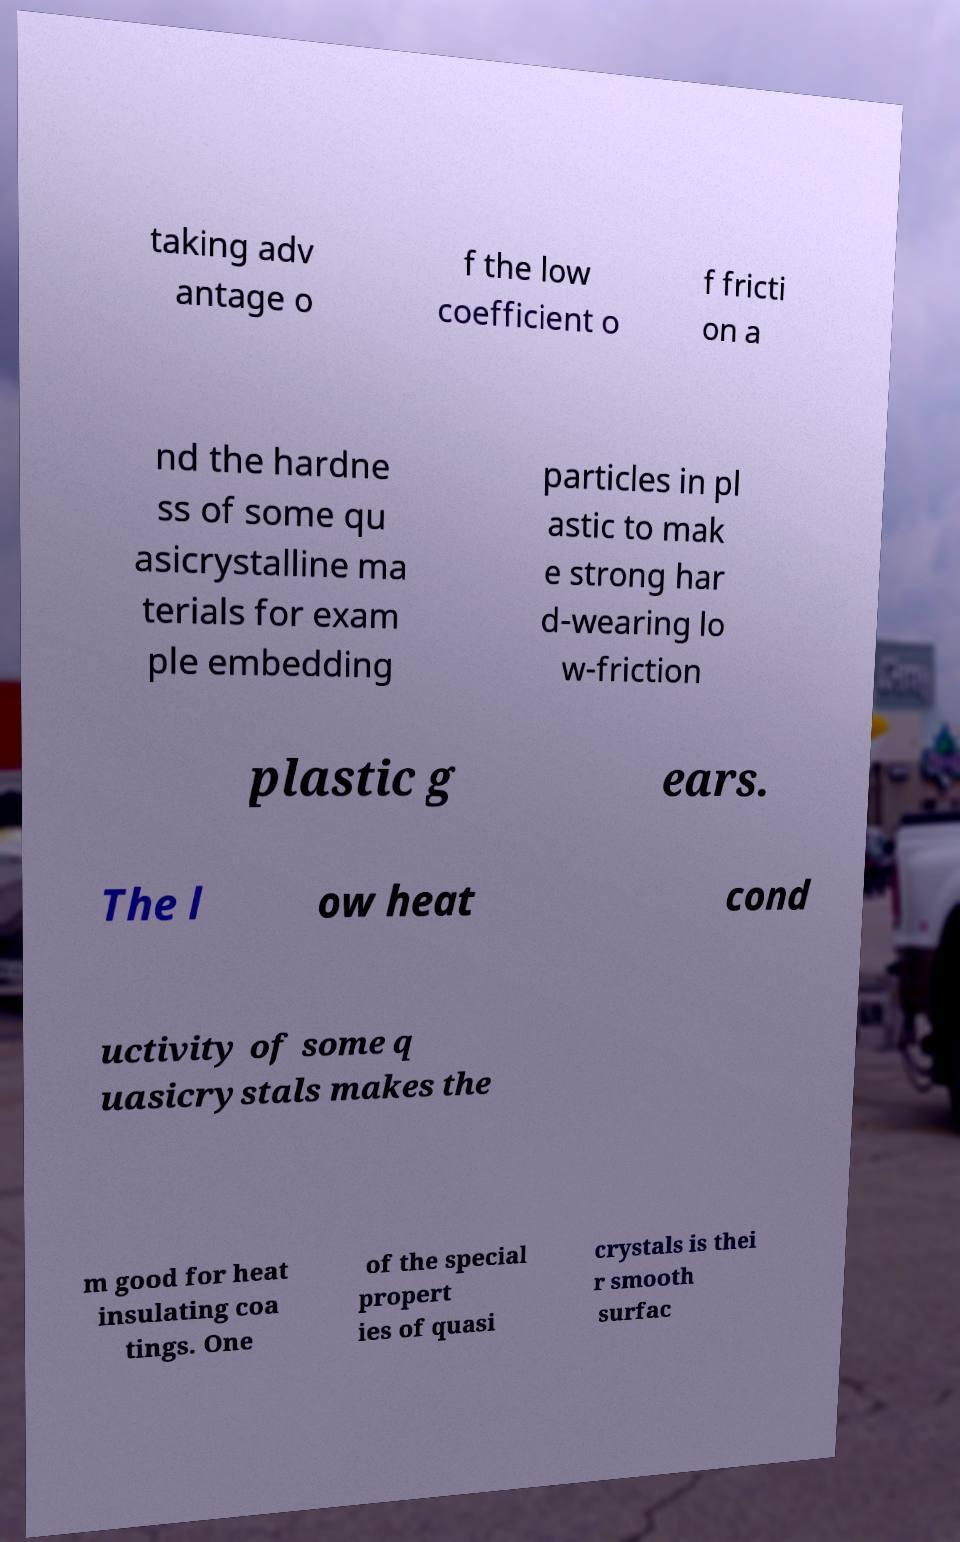There's text embedded in this image that I need extracted. Can you transcribe it verbatim? taking adv antage o f the low coefficient o f fricti on a nd the hardne ss of some qu asicrystalline ma terials for exam ple embedding particles in pl astic to mak e strong har d-wearing lo w-friction plastic g ears. The l ow heat cond uctivity of some q uasicrystals makes the m good for heat insulating coa tings. One of the special propert ies of quasi crystals is thei r smooth surfac 